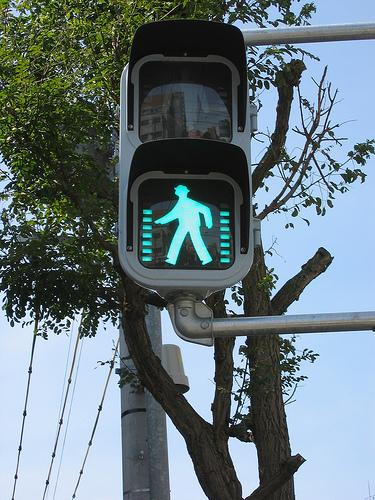Using vibrant language, describe the moment captured in the image. A pedestrian crosswalk basks under a cloudless azure sky, accompanied by verdant foliage and power lines gracefully curving in the background. Identify any infrastructure or urban elements seen in the photo. The main urban elements include a crosswalk traffic light with a green walk signal, utility poles with power lines, and a metal pole holding up the walk sign. Paint a picture of the scene using imaginative language. A vivid semaphore silently guides pedestrians amid nature's verdant embrace, as man-made cords waltz above under the watchful gaze of a cerulean expanse. Mention what the weather and time appear to be in the image. The weather appears to be clear and sunny, likely during the middle of the day, as indicated by the cloudless blue sky. Describe any natural elements present in the image. A tall green tree with leaves and branches, as well as a clear blue sky in the background. Provide a brief overview of the scene depicted in the image. A crosswalk traffic light with a green walk signal and a metal pole holding it up, a tree with green leaves and thin branches, and power lines in the background under a blue sky. List down the key colors seen in the image along with the objects they represent. Green - walk signal, tree leaves; Blue - sky; Brown - tree branches; Black - utility lines, metal poles; Gray - metal posts. Detail in one sentence the environment shown in the image. An urban street environment featuring a crosswalk signal, a tree, and utility lines against a cloudless blue sky. Enumerate three major elements present in the image. Crosswalk traffic light with green walk sign, tall green tree with leaves, utility lines and pole in the background. Explain the purpose of the primary object in the image. The primary object, the crosswalk traffic light, ensures pedestrian safety by displaying a green walk signal when it is safe to cross the street. Notice a picture of the ocean within the signal light at X:129 Y:62 Width:133 Height:133. The object mentioned in the image is a reflection of the city, not the ocean. Look for a section of the walkway crossing that is exceptionally well-lit at X:125 Y:61 Width:122 Height:122. The section of the walkway crossing mentioned in the image is actually not lit, not well-lit. Is there a wooden pole holding up the light at X:179 Y:311 Width:188 Height:188? The object mentioned in the image is a metal pole, not a wooden pole. Can you spot the red pants on the walkway figure at X:166 Y:231 Width:50 Height:50? The object mentioned in the image is actually green pants, not red. Can you find the red man on the walk sign located at X:154 Y:179 Width:65 Height:65? The object mentioned in the image is a green man on a walk sign, not red. Look for a blue walk sign on the black signal at X:97 Y:59 Width:206 Height:206. The object mentioned in the image is a green walk sign, not a blue walk sign. Observe a round metal construction on top of the pole at X:234 Y:20 Width:111 Height:111. The object mentioned in the image is an upper metal post, not a round metal construction. Is there a sign displaying a stop message at X:130 Y:26 Width:118 Height:118? The object mentioned in the image is a sign that is not lit up, not a sign displaying a stop message. Observe a blue sky filled with clouds around X:322 Y:345 Width:51 Height:51. The object mentioned in the image is a cloudless blue sky, not a sky filled with clouds. Can you find the grey leaves on the tree located at X:224 Y:321 Width:101 Height:101? The object mentioned in the image has green leaves, not grey. 